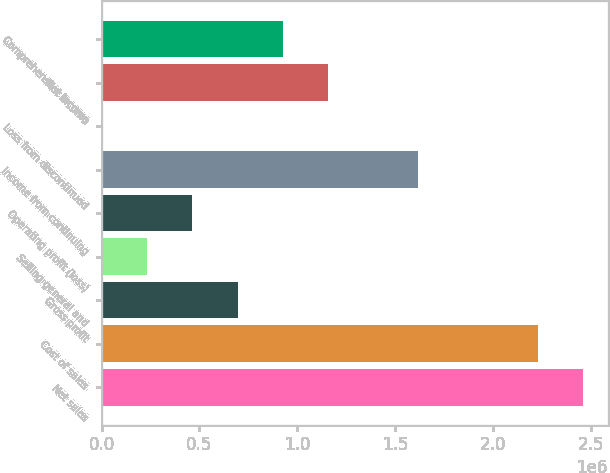<chart> <loc_0><loc_0><loc_500><loc_500><bar_chart><fcel>Net sales<fcel>Cost of sales<fcel>Gross profit<fcel>Selling general and<fcel>Operating profit (loss)<fcel>Income from continuing<fcel>Loss from discontinued<fcel>Net income<fcel>Comprehensive income<nl><fcel>2.4628e+06<fcel>2.23245e+06<fcel>695030<fcel>234333<fcel>464681<fcel>1.61642e+06<fcel>3985<fcel>1.15573e+06<fcel>925378<nl></chart> 